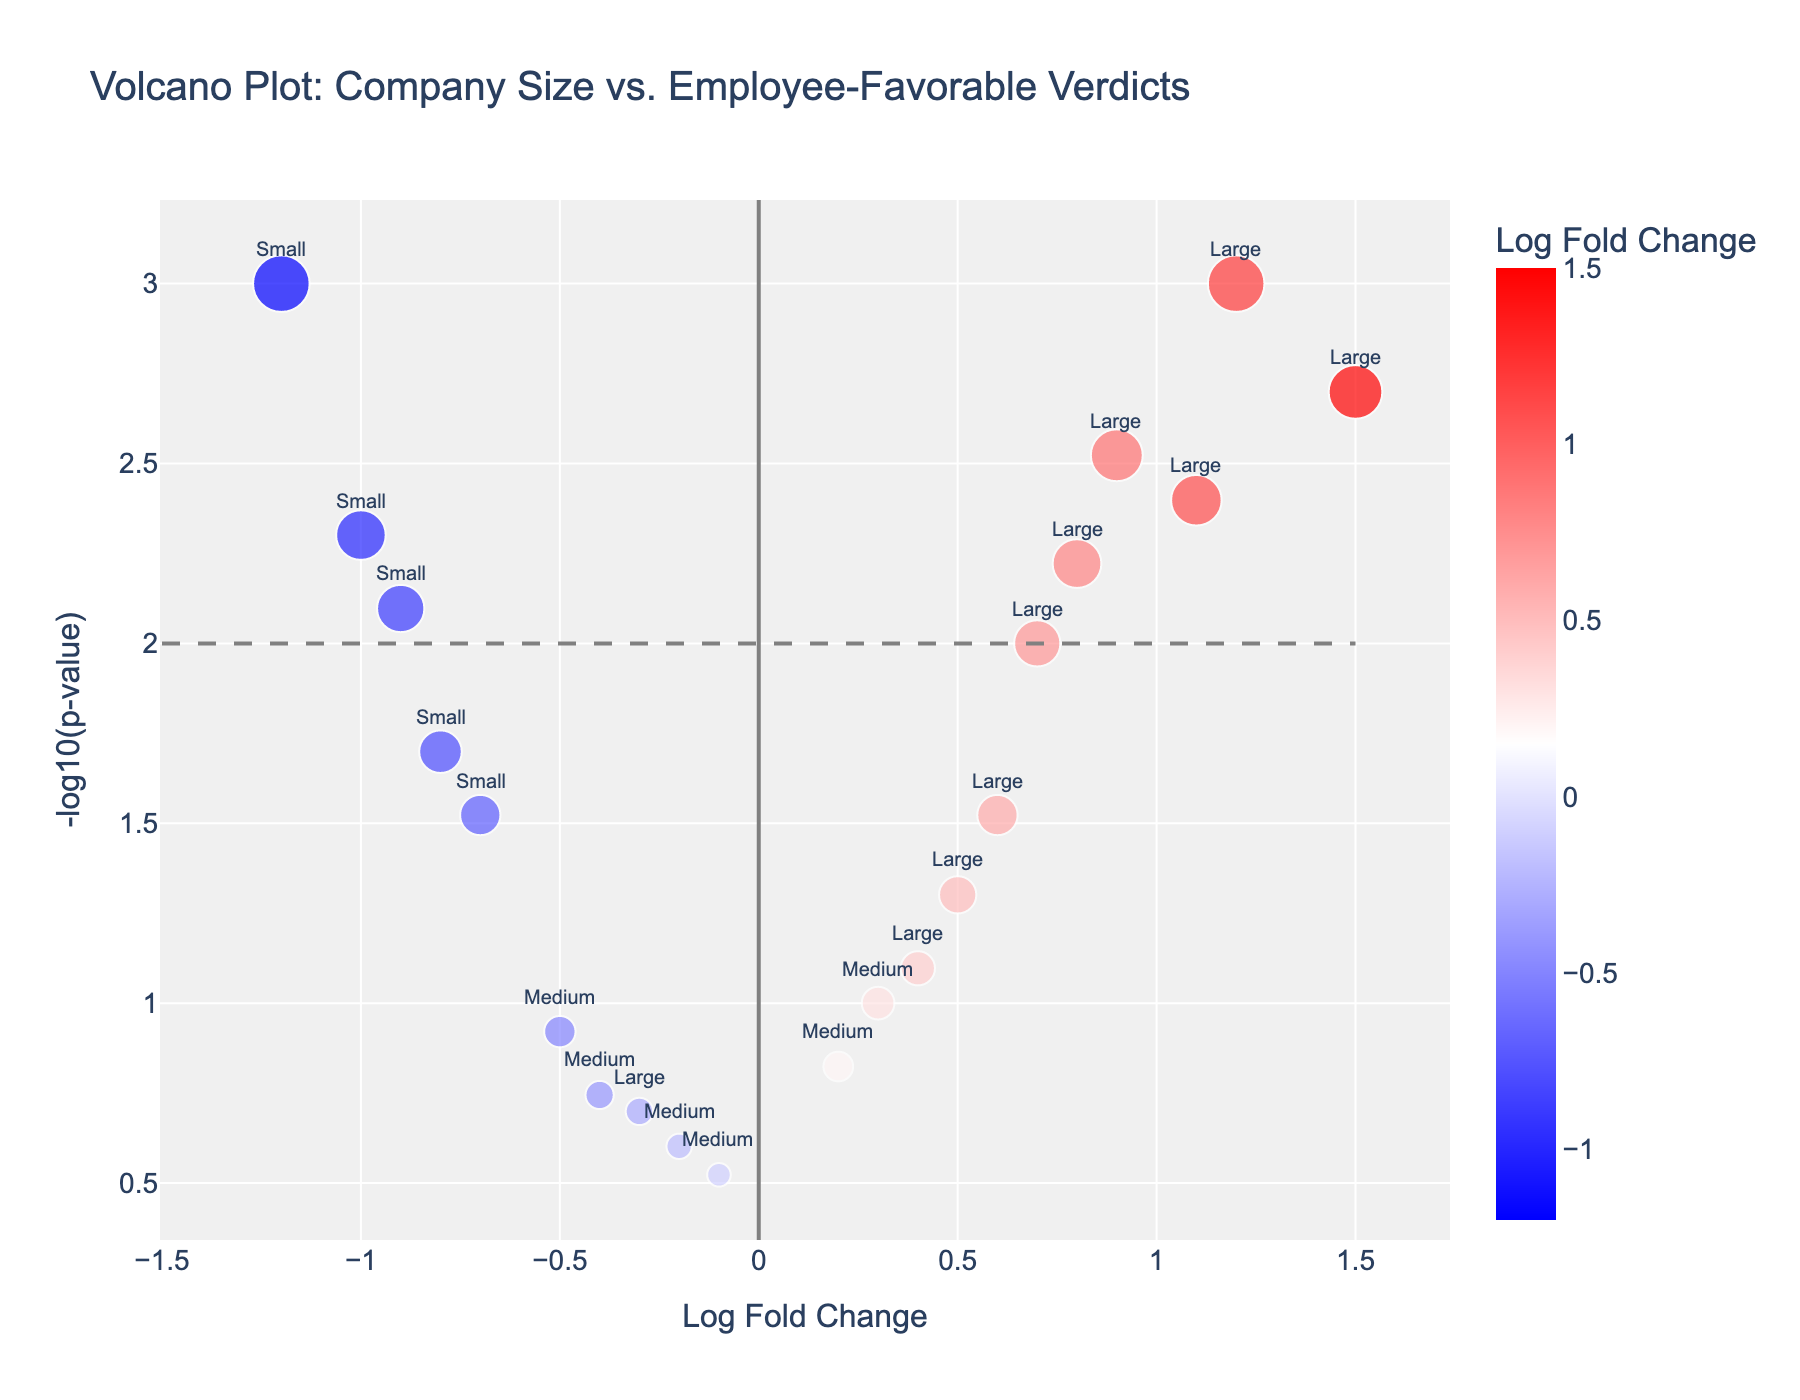How many companies are represented in the figure? To find the answer, count the total number of unique companies listed on the plot. By adding each distinct company, we see there are 20 companies represented.
Answer: 20 What is the log fold change and p-value threshold for significance in this plot? Look at the plot for the outlined thresholds. Log fold change has thresholds typically around ±1.5, and for p-value, you refer to the -log10(p-value) line set at 2. This corresponds to a p-value of 0.01, indicating significance.
Answer: ±1.5 for log fold change, 0.01 for p-value Which company has the highest log fold change? Identify the highest numerical value on the x-axis labeled 'Log Fold Change'. Amazon, with a log fold change of 1.5, has the highest value on the plot.
Answer: Amazon Which large-sized companies fall below the significance threshold (p-value > 0.01)? Examine the large-sized companies and check their corresponding -log10(p-value). Companies below a -log10(p-value) of 2 (logpvalue < 0.301) are considered non-significant. Target, Home Depot, FedEx do not meet the threshold.
Answer: Target, Home Depot, FedEx Are there any small-sized companies with significantly negative log fold changes? Look at small-sized companies and note their log fold change and p-value. Companies such as Local Bookstore, Family Restaurant, Boutique Shop are significantly negative (< -1.5) on the log fold change axis with p-values < 0.01.
Answer: Local Bookstore, Family Restaurant, Boutique Shop What range of -log10(p-value) values is annotated on the y-axis? Check the axis labeled -log10(p-value) for its range. On the given plot, it ranges from approximately 0 to 3.
Answer: 0 to 3 Which small-sized company exhibits the least negative log fold change? Compare the log fold change values of small-sized companies. The least negative value belongs to Tech Startup with a log fold change of -0.7.
Answer: Tech Startup How many large-sized companies have a positive log fold change? Review the data points representing large-sized companies and identify those with positive log fold changes. There are six such companies: Walmart, Google, Amazon, Apple, Microsoft, and UPS.
Answer: 6 What is the -log10(p-value) for the company "IBM"? Find IBM on the plot and trace its corresponding y-axis value. IBM's -log10(p-value) is around 2.
Answer: Around 2 